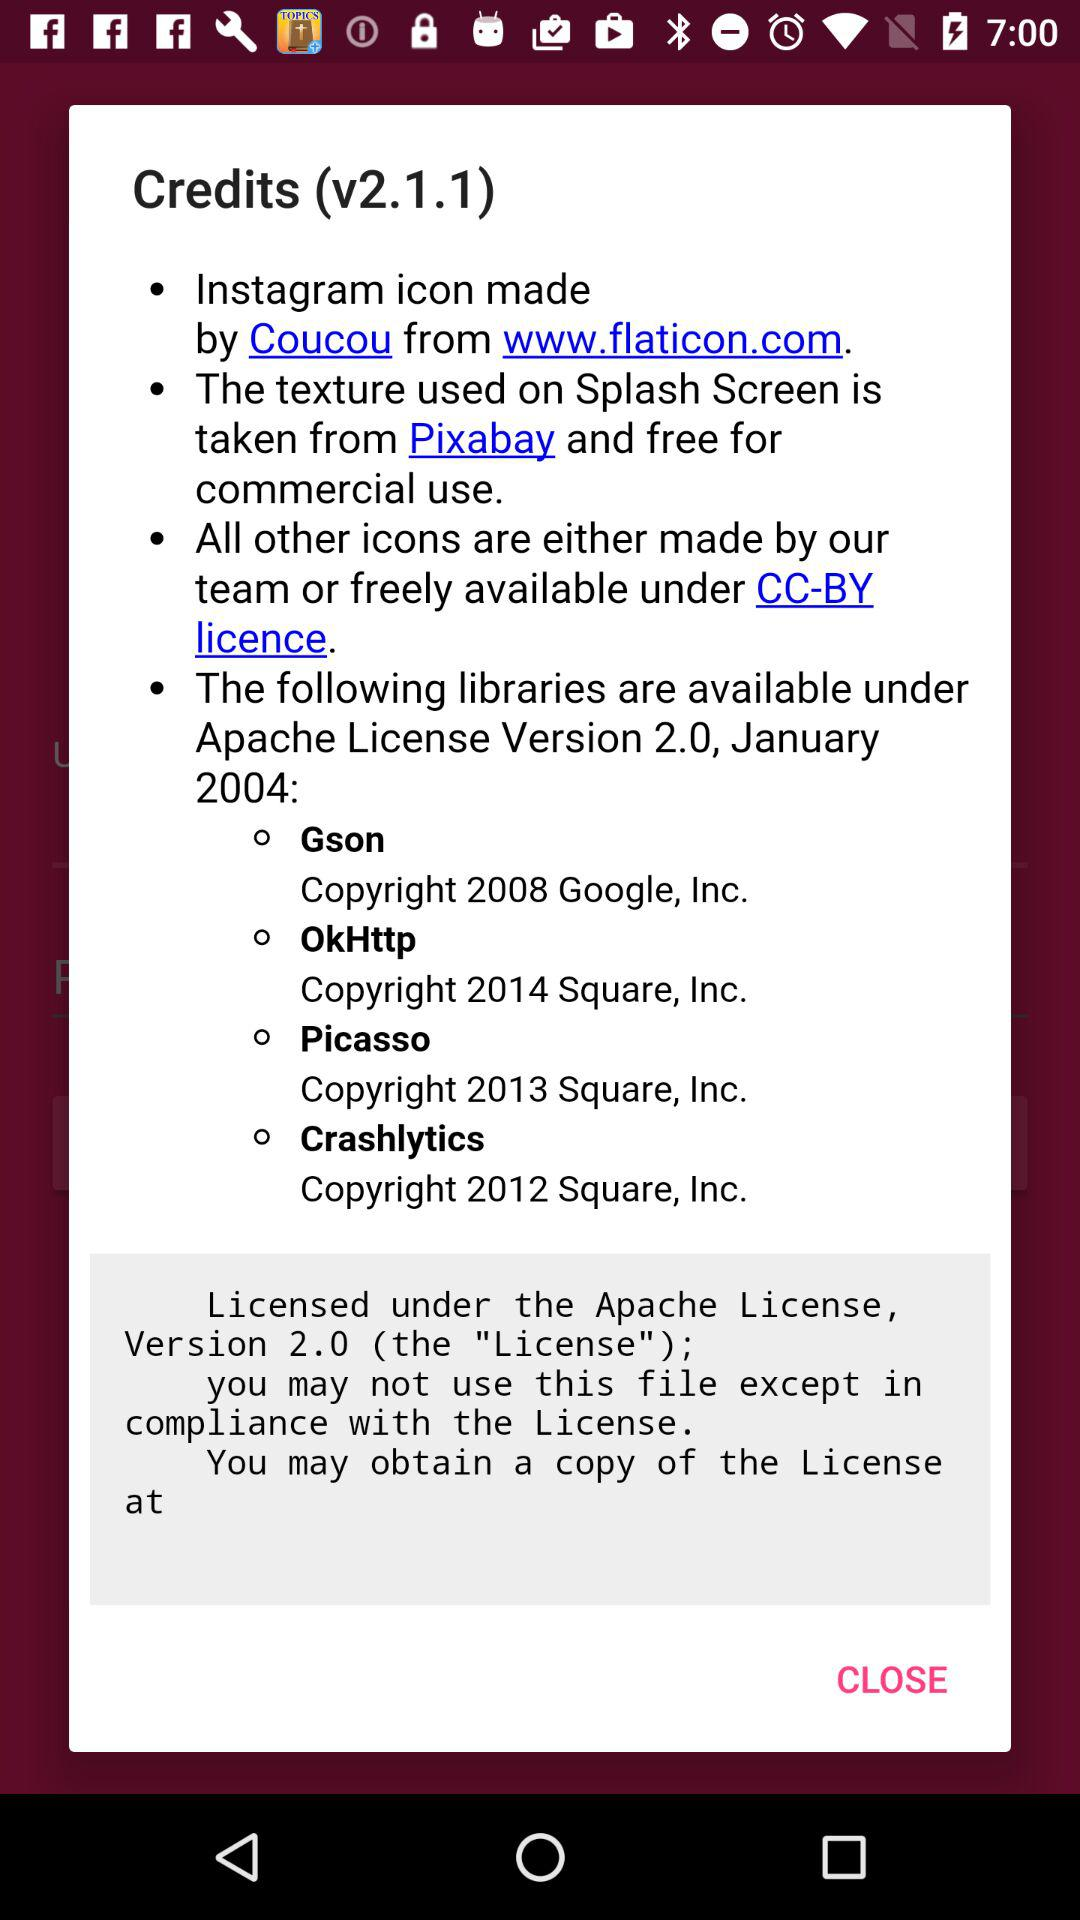How many open source libraries are available under Apache License Version 2.0?
Answer the question using a single word or phrase. 4 